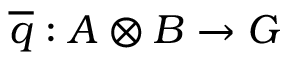Convert formula to latex. <formula><loc_0><loc_0><loc_500><loc_500>{ \overline { q } } \colon A \otimes B \to G</formula> 